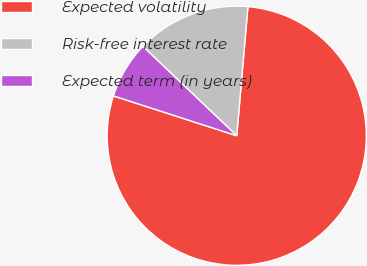Convert chart to OTSL. <chart><loc_0><loc_0><loc_500><loc_500><pie_chart><fcel>Expected volatility<fcel>Risk-free interest rate<fcel>Expected term (in years)<nl><fcel>78.6%<fcel>14.27%<fcel>7.13%<nl></chart> 